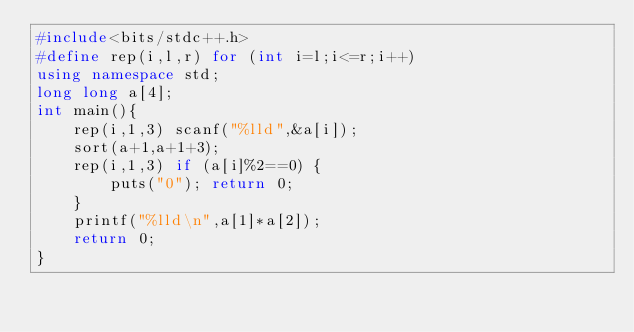Convert code to text. <code><loc_0><loc_0><loc_500><loc_500><_C++_>#include<bits/stdc++.h>
#define rep(i,l,r) for (int i=l;i<=r;i++)
using namespace std;
long long a[4];
int main(){
    rep(i,1,3) scanf("%lld",&a[i]);
    sort(a+1,a+1+3);
    rep(i,1,3) if (a[i]%2==0) {
        puts("0"); return 0;
    }
    printf("%lld\n",a[1]*a[2]);
    return 0;
}</code> 